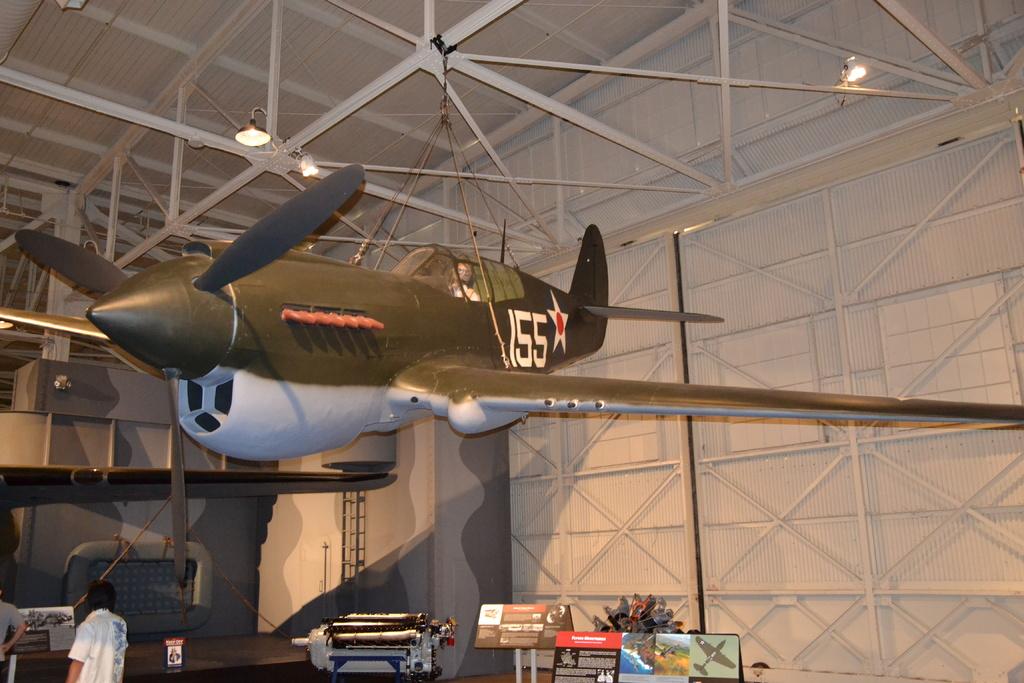What number is on the plane?
Your answer should be compact. 155. 